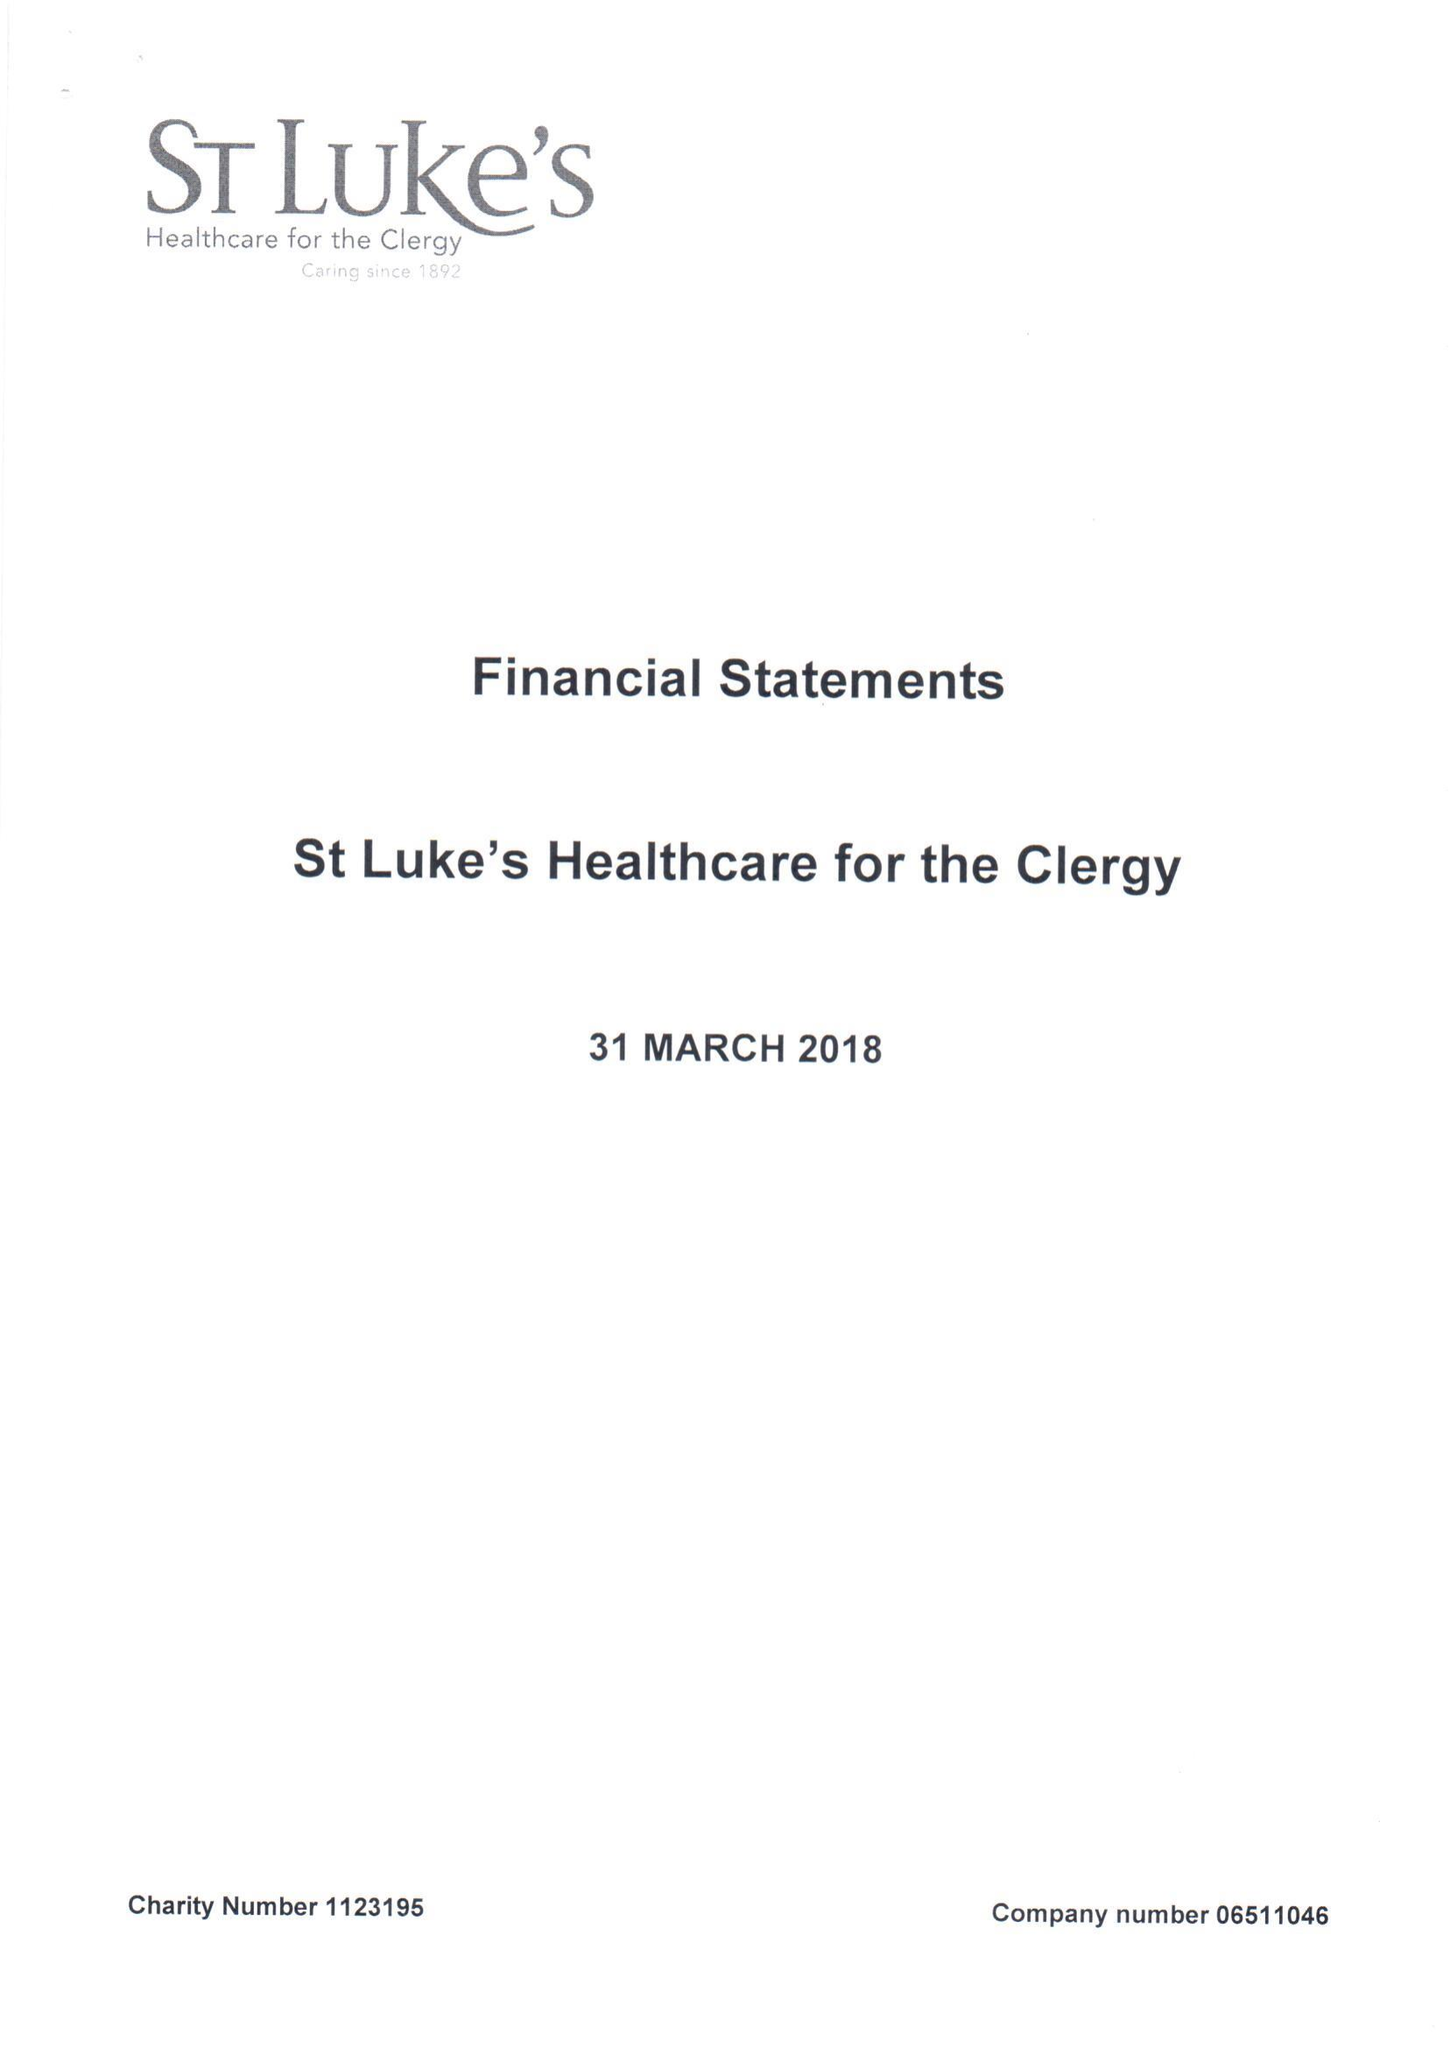What is the value for the address__postcode?
Answer the question using a single word or phrase. SW1P 3AZ 